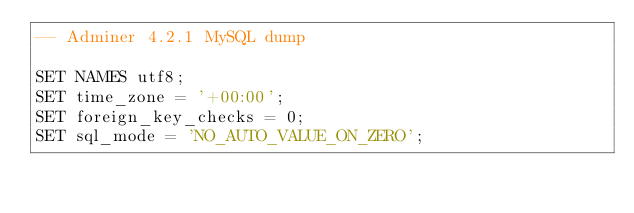<code> <loc_0><loc_0><loc_500><loc_500><_SQL_>-- Adminer 4.2.1 MySQL dump

SET NAMES utf8;
SET time_zone = '+00:00';
SET foreign_key_checks = 0;
SET sql_mode = 'NO_AUTO_VALUE_ON_ZERO';
</code> 